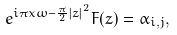<formula> <loc_0><loc_0><loc_500><loc_500>e ^ { i \pi x \omega - \frac { \pi } { 2 } \left | z \right | ^ { 2 } } F ( z ) = \alpha _ { i , j } ,</formula> 